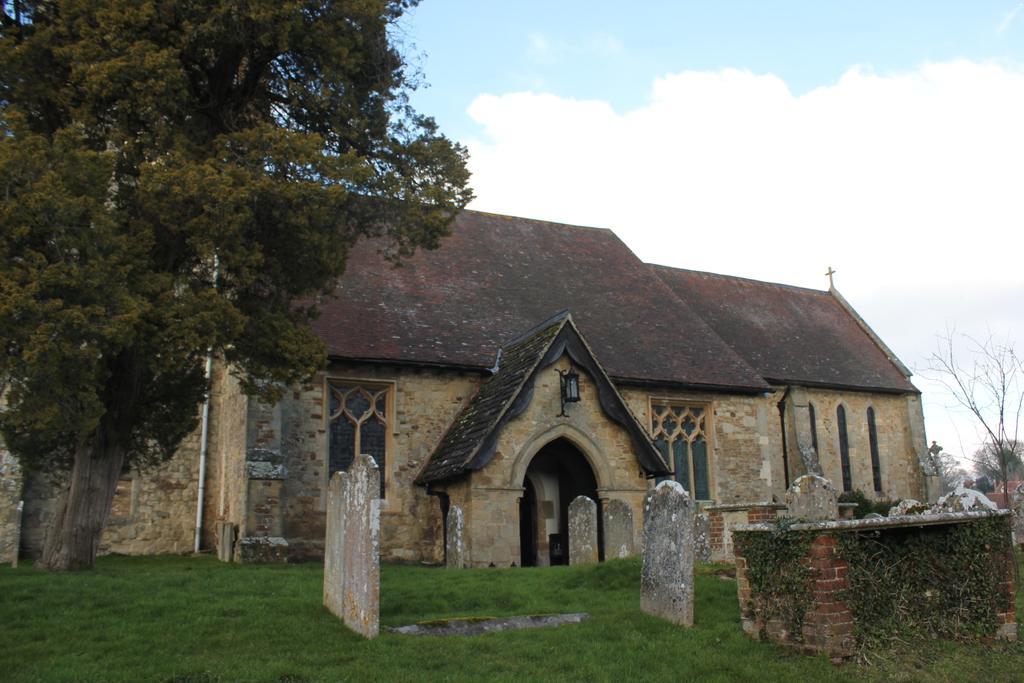In one or two sentences, can you explain what this image depicts? In this picture we can see the church. Here we can see windows and door. Here we can see light near to the entrance. On the bottom we can see grass and gravel. Here we can see sky and clouds. On the left we can see trees. 